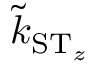<formula> <loc_0><loc_0><loc_500><loc_500>\tilde { k } _ { { S } { T } _ { z } }</formula> 